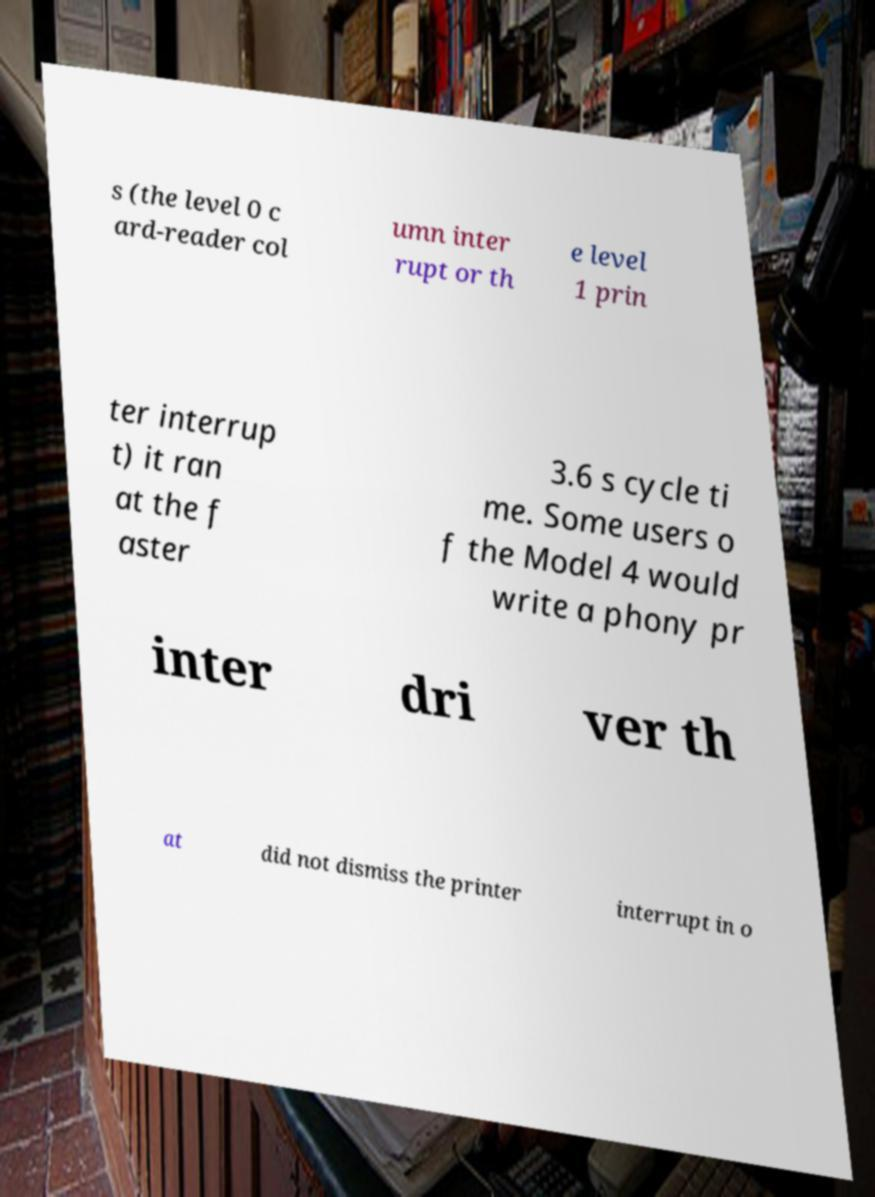For documentation purposes, I need the text within this image transcribed. Could you provide that? s (the level 0 c ard-reader col umn inter rupt or th e level 1 prin ter interrup t) it ran at the f aster 3.6 s cycle ti me. Some users o f the Model 4 would write a phony pr inter dri ver th at did not dismiss the printer interrupt in o 